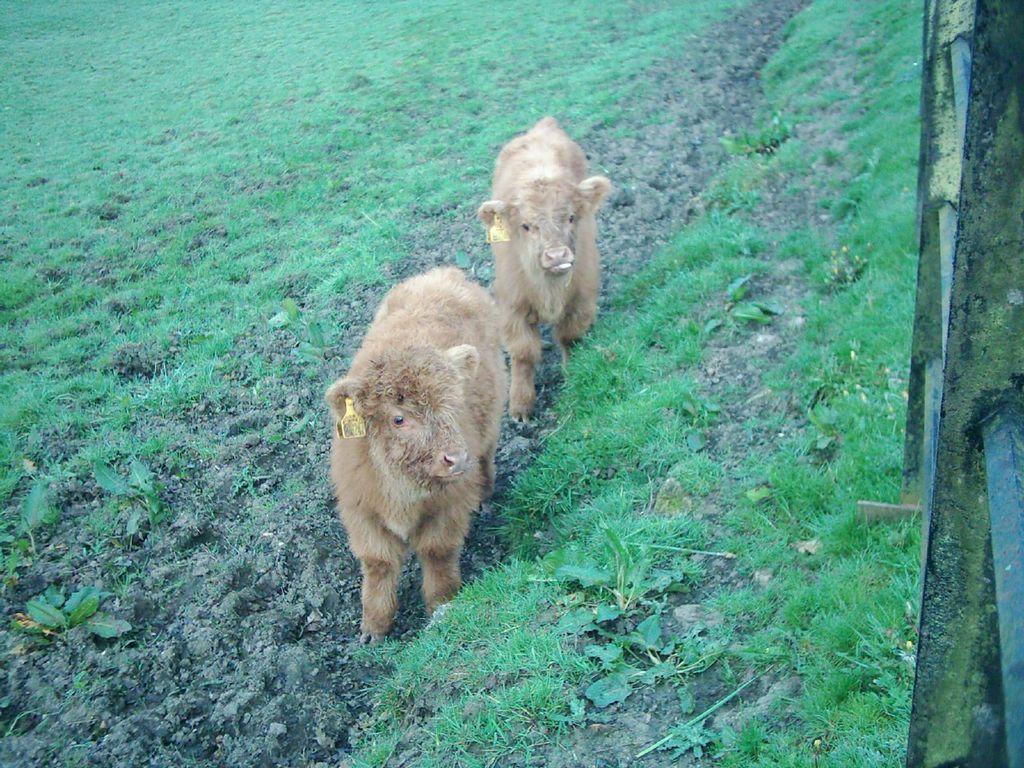Can you describe this image briefly? In this image we can see animals standing on the ground. In the background we can see grass. 